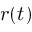<formula> <loc_0><loc_0><loc_500><loc_500>r ( t )</formula> 